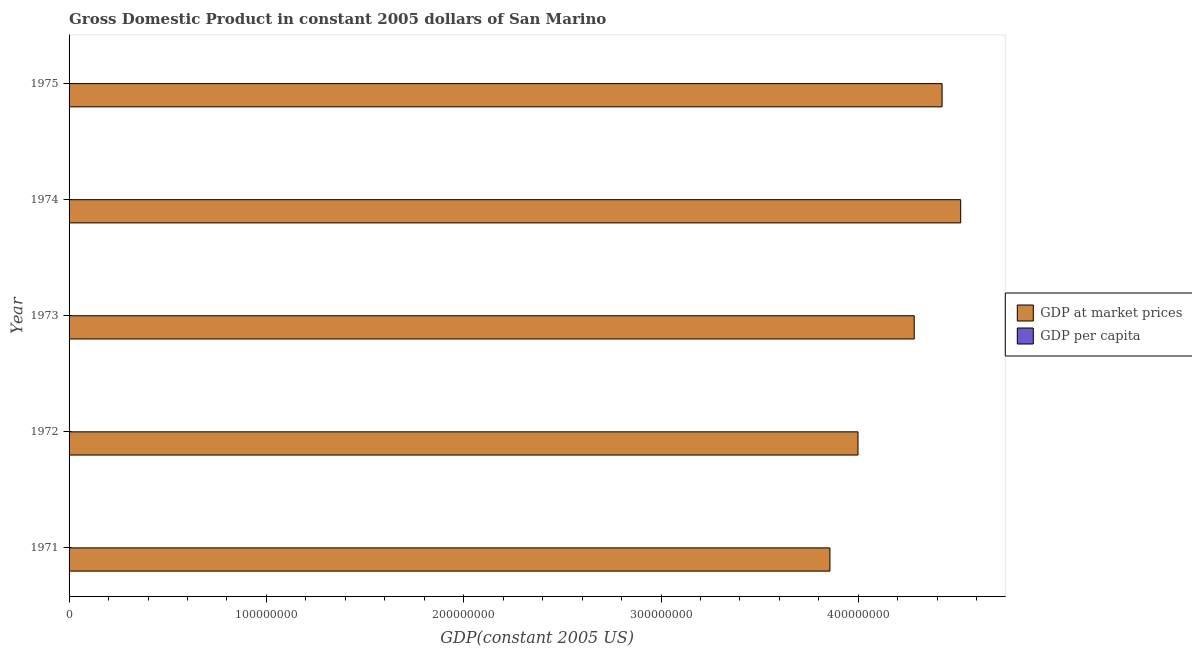How many groups of bars are there?
Provide a succinct answer. 5. Are the number of bars per tick equal to the number of legend labels?
Offer a terse response. Yes. How many bars are there on the 5th tick from the bottom?
Your answer should be very brief. 2. What is the gdp at market prices in 1975?
Offer a terse response. 4.42e+08. Across all years, what is the maximum gdp at market prices?
Give a very brief answer. 4.52e+08. Across all years, what is the minimum gdp per capita?
Offer a terse response. 2.00e+04. In which year was the gdp per capita maximum?
Ensure brevity in your answer.  1974. What is the total gdp per capita in the graph?
Ensure brevity in your answer.  1.08e+05. What is the difference between the gdp per capita in 1971 and that in 1975?
Offer a terse response. -2441.8. What is the difference between the gdp at market prices in 1974 and the gdp per capita in 1975?
Your answer should be compact. 4.52e+08. What is the average gdp at market prices per year?
Give a very brief answer. 4.22e+08. In the year 1971, what is the difference between the gdp at market prices and gdp per capita?
Your answer should be very brief. 3.86e+08. What is the ratio of the gdp per capita in 1971 to that in 1973?
Provide a short and direct response. 0.91. Is the gdp at market prices in 1974 less than that in 1975?
Your answer should be very brief. No. Is the difference between the gdp per capita in 1971 and 1974 greater than the difference between the gdp at market prices in 1971 and 1974?
Keep it short and to the point. Yes. What is the difference between the highest and the second highest gdp per capita?
Keep it short and to the point. 674.11. What is the difference between the highest and the lowest gdp per capita?
Keep it short and to the point. 3115.91. In how many years, is the gdp per capita greater than the average gdp per capita taken over all years?
Offer a very short reply. 3. What does the 2nd bar from the top in 1971 represents?
Your answer should be very brief. GDP at market prices. What does the 1st bar from the bottom in 1974 represents?
Ensure brevity in your answer.  GDP at market prices. How many bars are there?
Offer a terse response. 10. How many years are there in the graph?
Make the answer very short. 5. What is the difference between two consecutive major ticks on the X-axis?
Your answer should be very brief. 1.00e+08. Are the values on the major ticks of X-axis written in scientific E-notation?
Keep it short and to the point. No. Does the graph contain grids?
Your response must be concise. No. Where does the legend appear in the graph?
Ensure brevity in your answer.  Center right. What is the title of the graph?
Provide a short and direct response. Gross Domestic Product in constant 2005 dollars of San Marino. Does "Stunting" appear as one of the legend labels in the graph?
Your answer should be compact. No. What is the label or title of the X-axis?
Keep it short and to the point. GDP(constant 2005 US). What is the GDP(constant 2005 US) in GDP at market prices in 1971?
Provide a succinct answer. 3.86e+08. What is the GDP(constant 2005 US) of GDP per capita in 1971?
Provide a succinct answer. 2.00e+04. What is the GDP(constant 2005 US) of GDP at market prices in 1972?
Ensure brevity in your answer.  4.00e+08. What is the GDP(constant 2005 US) of GDP per capita in 1972?
Provide a succinct answer. 2.06e+04. What is the GDP(constant 2005 US) of GDP at market prices in 1973?
Ensure brevity in your answer.  4.28e+08. What is the GDP(constant 2005 US) of GDP per capita in 1973?
Your answer should be very brief. 2.20e+04. What is the GDP(constant 2005 US) of GDP at market prices in 1974?
Ensure brevity in your answer.  4.52e+08. What is the GDP(constant 2005 US) of GDP per capita in 1974?
Ensure brevity in your answer.  2.31e+04. What is the GDP(constant 2005 US) of GDP at market prices in 1975?
Your response must be concise. 4.42e+08. What is the GDP(constant 2005 US) in GDP per capita in 1975?
Your answer should be compact. 2.24e+04. Across all years, what is the maximum GDP(constant 2005 US) in GDP at market prices?
Your response must be concise. 4.52e+08. Across all years, what is the maximum GDP(constant 2005 US) of GDP per capita?
Keep it short and to the point. 2.31e+04. Across all years, what is the minimum GDP(constant 2005 US) of GDP at market prices?
Provide a succinct answer. 3.86e+08. Across all years, what is the minimum GDP(constant 2005 US) in GDP per capita?
Ensure brevity in your answer.  2.00e+04. What is the total GDP(constant 2005 US) in GDP at market prices in the graph?
Your answer should be compact. 2.11e+09. What is the total GDP(constant 2005 US) in GDP per capita in the graph?
Your response must be concise. 1.08e+05. What is the difference between the GDP(constant 2005 US) in GDP at market prices in 1971 and that in 1972?
Ensure brevity in your answer.  -1.42e+07. What is the difference between the GDP(constant 2005 US) in GDP per capita in 1971 and that in 1972?
Provide a succinct answer. -633.75. What is the difference between the GDP(constant 2005 US) of GDP at market prices in 1971 and that in 1973?
Keep it short and to the point. -4.27e+07. What is the difference between the GDP(constant 2005 US) of GDP per capita in 1971 and that in 1973?
Ensure brevity in your answer.  -2022.08. What is the difference between the GDP(constant 2005 US) in GDP at market prices in 1971 and that in 1974?
Your answer should be compact. -6.63e+07. What is the difference between the GDP(constant 2005 US) of GDP per capita in 1971 and that in 1974?
Your answer should be very brief. -3115.91. What is the difference between the GDP(constant 2005 US) in GDP at market prices in 1971 and that in 1975?
Provide a succinct answer. -5.68e+07. What is the difference between the GDP(constant 2005 US) of GDP per capita in 1971 and that in 1975?
Your answer should be compact. -2441.8. What is the difference between the GDP(constant 2005 US) of GDP at market prices in 1972 and that in 1973?
Your answer should be very brief. -2.85e+07. What is the difference between the GDP(constant 2005 US) in GDP per capita in 1972 and that in 1973?
Give a very brief answer. -1388.33. What is the difference between the GDP(constant 2005 US) of GDP at market prices in 1972 and that in 1974?
Your answer should be very brief. -5.20e+07. What is the difference between the GDP(constant 2005 US) of GDP per capita in 1972 and that in 1974?
Offer a terse response. -2482.16. What is the difference between the GDP(constant 2005 US) in GDP at market prices in 1972 and that in 1975?
Your answer should be compact. -4.26e+07. What is the difference between the GDP(constant 2005 US) of GDP per capita in 1972 and that in 1975?
Provide a succinct answer. -1808.05. What is the difference between the GDP(constant 2005 US) in GDP at market prices in 1973 and that in 1974?
Provide a short and direct response. -2.36e+07. What is the difference between the GDP(constant 2005 US) of GDP per capita in 1973 and that in 1974?
Your answer should be compact. -1093.83. What is the difference between the GDP(constant 2005 US) in GDP at market prices in 1973 and that in 1975?
Your response must be concise. -1.41e+07. What is the difference between the GDP(constant 2005 US) of GDP per capita in 1973 and that in 1975?
Make the answer very short. -419.72. What is the difference between the GDP(constant 2005 US) of GDP at market prices in 1974 and that in 1975?
Offer a terse response. 9.44e+06. What is the difference between the GDP(constant 2005 US) of GDP per capita in 1974 and that in 1975?
Offer a very short reply. 674.11. What is the difference between the GDP(constant 2005 US) in GDP at market prices in 1971 and the GDP(constant 2005 US) in GDP per capita in 1972?
Ensure brevity in your answer.  3.86e+08. What is the difference between the GDP(constant 2005 US) in GDP at market prices in 1971 and the GDP(constant 2005 US) in GDP per capita in 1973?
Give a very brief answer. 3.86e+08. What is the difference between the GDP(constant 2005 US) of GDP at market prices in 1971 and the GDP(constant 2005 US) of GDP per capita in 1974?
Make the answer very short. 3.86e+08. What is the difference between the GDP(constant 2005 US) of GDP at market prices in 1971 and the GDP(constant 2005 US) of GDP per capita in 1975?
Your answer should be compact. 3.86e+08. What is the difference between the GDP(constant 2005 US) of GDP at market prices in 1972 and the GDP(constant 2005 US) of GDP per capita in 1973?
Your response must be concise. 4.00e+08. What is the difference between the GDP(constant 2005 US) of GDP at market prices in 1972 and the GDP(constant 2005 US) of GDP per capita in 1974?
Make the answer very short. 4.00e+08. What is the difference between the GDP(constant 2005 US) in GDP at market prices in 1972 and the GDP(constant 2005 US) in GDP per capita in 1975?
Provide a short and direct response. 4.00e+08. What is the difference between the GDP(constant 2005 US) in GDP at market prices in 1973 and the GDP(constant 2005 US) in GDP per capita in 1974?
Provide a succinct answer. 4.28e+08. What is the difference between the GDP(constant 2005 US) in GDP at market prices in 1973 and the GDP(constant 2005 US) in GDP per capita in 1975?
Keep it short and to the point. 4.28e+08. What is the difference between the GDP(constant 2005 US) of GDP at market prices in 1974 and the GDP(constant 2005 US) of GDP per capita in 1975?
Keep it short and to the point. 4.52e+08. What is the average GDP(constant 2005 US) of GDP at market prices per year?
Make the answer very short. 4.22e+08. What is the average GDP(constant 2005 US) of GDP per capita per year?
Keep it short and to the point. 2.16e+04. In the year 1971, what is the difference between the GDP(constant 2005 US) in GDP at market prices and GDP(constant 2005 US) in GDP per capita?
Your response must be concise. 3.86e+08. In the year 1972, what is the difference between the GDP(constant 2005 US) in GDP at market prices and GDP(constant 2005 US) in GDP per capita?
Make the answer very short. 4.00e+08. In the year 1973, what is the difference between the GDP(constant 2005 US) of GDP at market prices and GDP(constant 2005 US) of GDP per capita?
Ensure brevity in your answer.  4.28e+08. In the year 1974, what is the difference between the GDP(constant 2005 US) of GDP at market prices and GDP(constant 2005 US) of GDP per capita?
Keep it short and to the point. 4.52e+08. In the year 1975, what is the difference between the GDP(constant 2005 US) in GDP at market prices and GDP(constant 2005 US) in GDP per capita?
Your answer should be compact. 4.42e+08. What is the ratio of the GDP(constant 2005 US) in GDP at market prices in 1971 to that in 1972?
Make the answer very short. 0.96. What is the ratio of the GDP(constant 2005 US) of GDP per capita in 1971 to that in 1972?
Provide a short and direct response. 0.97. What is the ratio of the GDP(constant 2005 US) of GDP at market prices in 1971 to that in 1973?
Provide a short and direct response. 0.9. What is the ratio of the GDP(constant 2005 US) of GDP per capita in 1971 to that in 1973?
Provide a succinct answer. 0.91. What is the ratio of the GDP(constant 2005 US) of GDP at market prices in 1971 to that in 1974?
Give a very brief answer. 0.85. What is the ratio of the GDP(constant 2005 US) of GDP per capita in 1971 to that in 1974?
Keep it short and to the point. 0.87. What is the ratio of the GDP(constant 2005 US) of GDP at market prices in 1971 to that in 1975?
Give a very brief answer. 0.87. What is the ratio of the GDP(constant 2005 US) in GDP per capita in 1971 to that in 1975?
Offer a very short reply. 0.89. What is the ratio of the GDP(constant 2005 US) in GDP at market prices in 1972 to that in 1973?
Keep it short and to the point. 0.93. What is the ratio of the GDP(constant 2005 US) of GDP per capita in 1972 to that in 1973?
Ensure brevity in your answer.  0.94. What is the ratio of the GDP(constant 2005 US) of GDP at market prices in 1972 to that in 1974?
Provide a succinct answer. 0.88. What is the ratio of the GDP(constant 2005 US) of GDP per capita in 1972 to that in 1974?
Offer a very short reply. 0.89. What is the ratio of the GDP(constant 2005 US) of GDP at market prices in 1972 to that in 1975?
Your answer should be very brief. 0.9. What is the ratio of the GDP(constant 2005 US) in GDP per capita in 1972 to that in 1975?
Offer a very short reply. 0.92. What is the ratio of the GDP(constant 2005 US) in GDP at market prices in 1973 to that in 1974?
Give a very brief answer. 0.95. What is the ratio of the GDP(constant 2005 US) of GDP per capita in 1973 to that in 1974?
Provide a succinct answer. 0.95. What is the ratio of the GDP(constant 2005 US) of GDP at market prices in 1973 to that in 1975?
Provide a succinct answer. 0.97. What is the ratio of the GDP(constant 2005 US) in GDP per capita in 1973 to that in 1975?
Provide a short and direct response. 0.98. What is the ratio of the GDP(constant 2005 US) of GDP at market prices in 1974 to that in 1975?
Provide a succinct answer. 1.02. What is the ratio of the GDP(constant 2005 US) in GDP per capita in 1974 to that in 1975?
Your response must be concise. 1.03. What is the difference between the highest and the second highest GDP(constant 2005 US) of GDP at market prices?
Offer a terse response. 9.44e+06. What is the difference between the highest and the second highest GDP(constant 2005 US) of GDP per capita?
Offer a terse response. 674.11. What is the difference between the highest and the lowest GDP(constant 2005 US) of GDP at market prices?
Your answer should be compact. 6.63e+07. What is the difference between the highest and the lowest GDP(constant 2005 US) in GDP per capita?
Provide a short and direct response. 3115.91. 